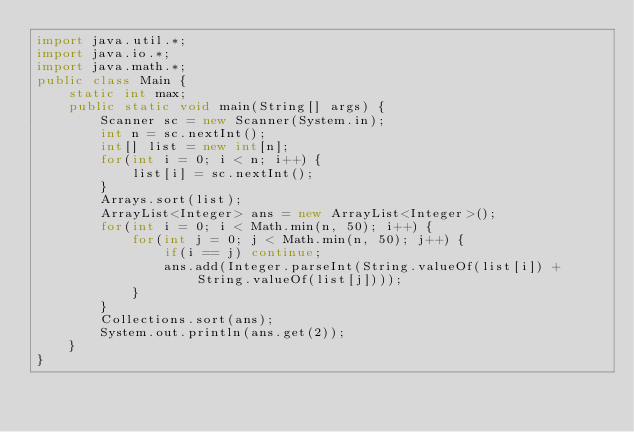<code> <loc_0><loc_0><loc_500><loc_500><_Java_>import java.util.*;
import java.io.*;
import java.math.*;
public class Main {
	static int max;
	public static void main(String[] args) {
		Scanner sc = new Scanner(System.in);
		int n = sc.nextInt();
		int[] list = new int[n];
		for(int i = 0; i < n; i++) {
			list[i] = sc.nextInt();
		}
		Arrays.sort(list);
		ArrayList<Integer> ans = new ArrayList<Integer>();
		for(int i = 0; i < Math.min(n, 50); i++) {
			for(int j = 0; j < Math.min(n, 50); j++) {
				if(i == j) continue;
				ans.add(Integer.parseInt(String.valueOf(list[i]) + String.valueOf(list[j])));
			}
		}
		Collections.sort(ans);
		System.out.println(ans.get(2));
	}
}</code> 